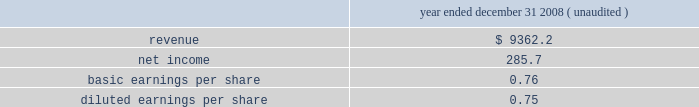Acquired is represented by allied 2019s infrastructure of market-based collection routes and its related integrated waste transfer and disposal channels , whose value has been included in goodwill .
All of the goodwill and other intangible assets resulting from the allied acquisition are not deductible for income tax purposes .
Pro forma information the consolidated financial statements presented for republic include the operating results of allied from december 5 , 2008 , the date of the acquisition .
The following pro forma information is presented assuming the acquisition had been completed as of january 1 , 2008 .
The unaudited pro forma information presented has been prepared for illustrative purposes and is not intended to be indicative of the results of operations that would have actually occurred had the acquisition been consummated at the beginning of the periods presented or of future results of the combined operations .
Furthermore , the pro forma results do not give effect to all cost savings or incremental costs that occur as a result of the integration and consolidation of the acquisition ( in millions , except share and per share amounts ) .
Year ended december 31 , ( unaudited ) .
The unaudited pro forma financial information includes adjustments for amortization of identifiable intangible assets , accretion of discounts to fair value associated with debt , environmental , self-insurance and other liabilities , accretion of capping , closure and post-closure obligations and amortization of the related assets , and provision for income taxes .
Restructuring charges as a result of the 2008 allied acquisition , we committed to a restructuring plan related to our corporate overhead and other administrative and operating functions .
The plan included closing our corporate office in florida , consolidating administrative functions to arizona , the former headquarters of allied , and reducing staffing levels .
The plan also included closing and consolidating certain operating locations and terminating certain leases .
During the years ended december 31 , 2010 and 2009 , we incurred $ 11.4 million , net of adjustments , and $ 63.2 million , respectively , of restructuring and integration charges related to our integration of allied .
These charges and adjustments primarily related to severance and other employee termination and relocation benefits and consulting and professional fees .
Substantially all the charges are recorded in our corporate segment .
We do not expect to incur additional charges to complete our plan .
We expect that the remaining charges will be paid during 2011 .
Republic services , inc .
Notes to consolidated financial statements , continued .
What was the ratio of the restructuring and integration charges related to our integration of allied for 2009 to 2010? 
Rationale: the ratio of the restructuring and integration charges related to our integration of allied for 2009 to 2010 was 23 to 1
Computations: (63.2 / 11.4)
Answer: 5.54386. 